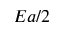<formula> <loc_0><loc_0><loc_500><loc_500>E a / 2</formula> 